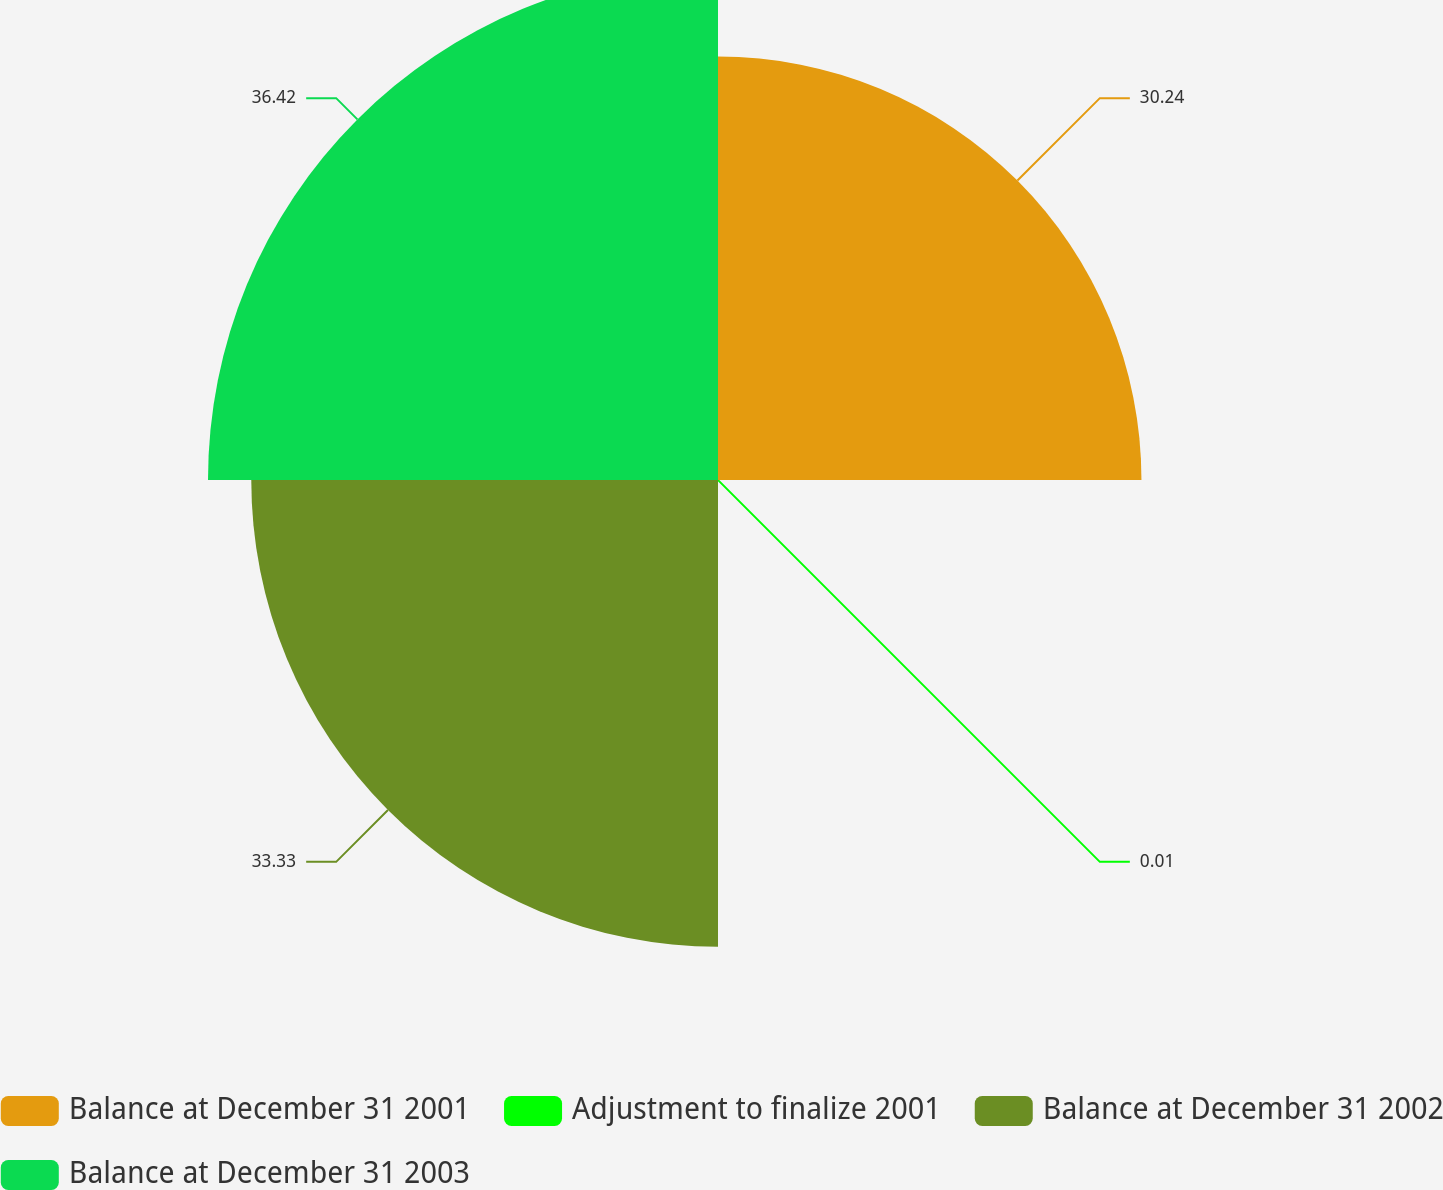Convert chart to OTSL. <chart><loc_0><loc_0><loc_500><loc_500><pie_chart><fcel>Balance at December 31 2001<fcel>Adjustment to finalize 2001<fcel>Balance at December 31 2002<fcel>Balance at December 31 2003<nl><fcel>30.24%<fcel>0.01%<fcel>33.33%<fcel>36.42%<nl></chart> 